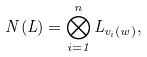<formula> <loc_0><loc_0><loc_500><loc_500>N ( L ) = \bigotimes _ { i = 1 } ^ { n } L _ { v _ { i } ( w ) } ,</formula> 